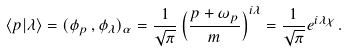Convert formula to latex. <formula><loc_0><loc_0><loc_500><loc_500>\langle p | \lambda \rangle = ( \phi _ { p } \, , \phi _ { \lambda } ) _ { \alpha } = \frac { 1 } { \sqrt { \pi } } \left ( \frac { p + \omega _ { p } } { m } \right ) ^ { i \lambda } = \frac { 1 } { \sqrt { \pi } } e ^ { i \lambda \chi } \, .</formula> 